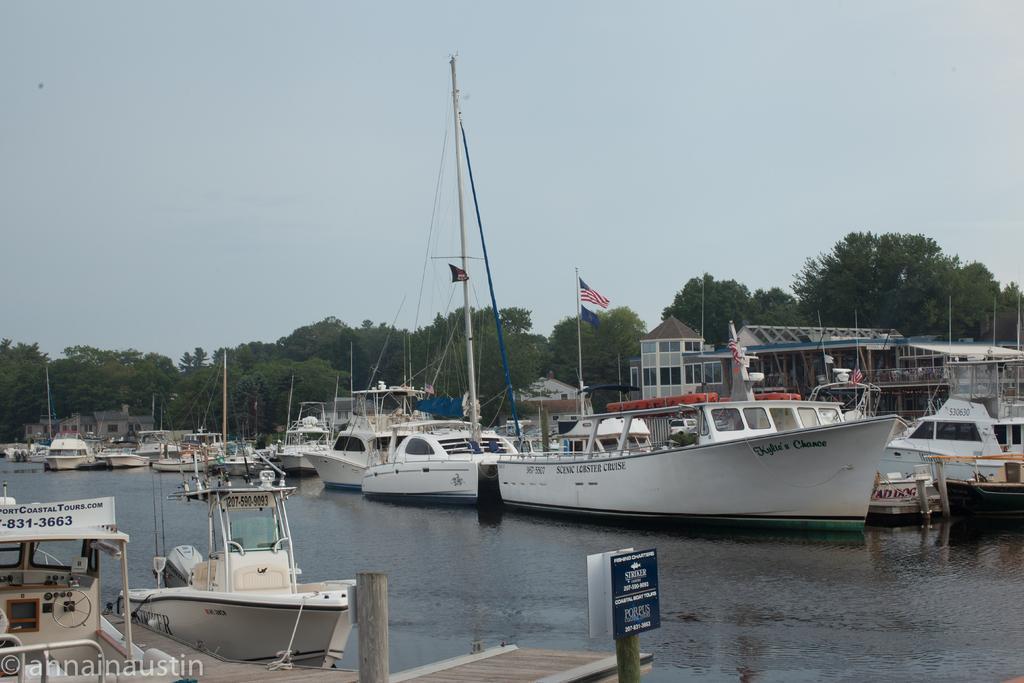How would you summarize this image in a sentence or two? In this image I can see water and on it I can see number of boats. In the background I can see number of trees, the sky and few flags. On the bottom side of this image I can see few boards and on it I can see something is written. 